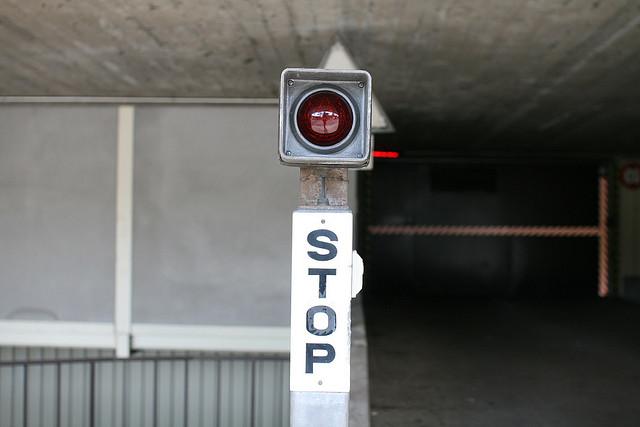What shape is the stop sign?
Keep it brief. Rectangle. Where is the sign stopping you from going?
Give a very brief answer. In. What does the light do?
Be succinct. Stop. 